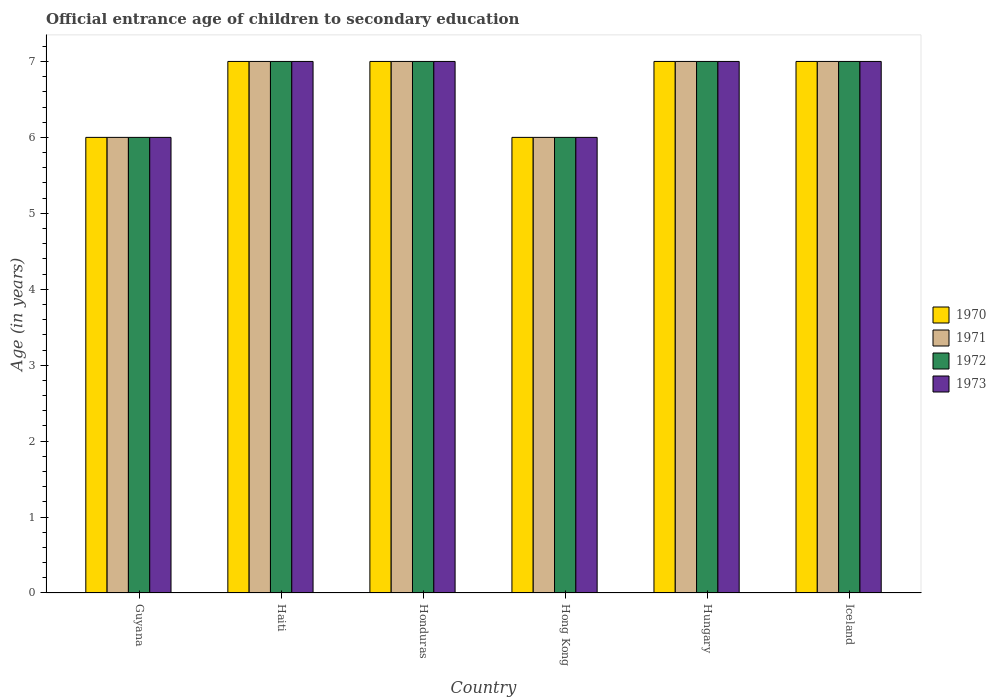Are the number of bars per tick equal to the number of legend labels?
Your answer should be compact. Yes. How many bars are there on the 3rd tick from the right?
Make the answer very short. 4. What is the label of the 1st group of bars from the left?
Offer a terse response. Guyana. Across all countries, what is the minimum secondary school starting age of children in 1973?
Provide a succinct answer. 6. In which country was the secondary school starting age of children in 1973 maximum?
Provide a short and direct response. Haiti. In which country was the secondary school starting age of children in 1972 minimum?
Your response must be concise. Guyana. What is the difference between the secondary school starting age of children in 1972 in Haiti and that in Hungary?
Offer a terse response. 0. What is the average secondary school starting age of children in 1971 per country?
Your answer should be compact. 6.67. What is the difference between the secondary school starting age of children of/in 1971 and secondary school starting age of children of/in 1973 in Hungary?
Give a very brief answer. 0. In how many countries, is the secondary school starting age of children in 1970 greater than 5.8 years?
Provide a short and direct response. 6. What is the ratio of the secondary school starting age of children in 1970 in Guyana to that in Haiti?
Your answer should be compact. 0.86. Is the secondary school starting age of children in 1970 in Guyana less than that in Hungary?
Ensure brevity in your answer.  Yes. What does the 3rd bar from the right in Guyana represents?
Make the answer very short. 1971. How many bars are there?
Your answer should be compact. 24. How many countries are there in the graph?
Keep it short and to the point. 6. What is the title of the graph?
Make the answer very short. Official entrance age of children to secondary education. Does "1998" appear as one of the legend labels in the graph?
Ensure brevity in your answer.  No. What is the label or title of the Y-axis?
Your response must be concise. Age (in years). What is the Age (in years) in 1972 in Guyana?
Make the answer very short. 6. What is the Age (in years) in 1970 in Haiti?
Give a very brief answer. 7. What is the Age (in years) in 1971 in Haiti?
Your answer should be very brief. 7. What is the Age (in years) of 1972 in Haiti?
Offer a very short reply. 7. What is the Age (in years) in 1973 in Haiti?
Keep it short and to the point. 7. What is the Age (in years) in 1970 in Honduras?
Your response must be concise. 7. What is the Age (in years) of 1973 in Honduras?
Your response must be concise. 7. What is the Age (in years) of 1970 in Hong Kong?
Offer a terse response. 6. What is the Age (in years) of 1973 in Hong Kong?
Keep it short and to the point. 6. What is the Age (in years) in 1970 in Hungary?
Offer a terse response. 7. What is the Age (in years) in 1972 in Hungary?
Your answer should be very brief. 7. What is the Age (in years) of 1973 in Hungary?
Your response must be concise. 7. What is the Age (in years) in 1973 in Iceland?
Give a very brief answer. 7. Across all countries, what is the minimum Age (in years) in 1973?
Provide a short and direct response. 6. What is the total Age (in years) in 1970 in the graph?
Keep it short and to the point. 40. What is the total Age (in years) of 1971 in the graph?
Keep it short and to the point. 40. What is the total Age (in years) in 1972 in the graph?
Offer a terse response. 40. What is the total Age (in years) in 1973 in the graph?
Your answer should be very brief. 40. What is the difference between the Age (in years) in 1970 in Guyana and that in Haiti?
Keep it short and to the point. -1. What is the difference between the Age (in years) of 1972 in Guyana and that in Haiti?
Your answer should be very brief. -1. What is the difference between the Age (in years) of 1971 in Guyana and that in Honduras?
Offer a terse response. -1. What is the difference between the Age (in years) of 1973 in Guyana and that in Honduras?
Keep it short and to the point. -1. What is the difference between the Age (in years) of 1970 in Guyana and that in Hong Kong?
Give a very brief answer. 0. What is the difference between the Age (in years) in 1970 in Guyana and that in Hungary?
Make the answer very short. -1. What is the difference between the Age (in years) of 1972 in Guyana and that in Hungary?
Provide a short and direct response. -1. What is the difference between the Age (in years) in 1973 in Guyana and that in Hungary?
Your response must be concise. -1. What is the difference between the Age (in years) in 1970 in Guyana and that in Iceland?
Your response must be concise. -1. What is the difference between the Age (in years) of 1972 in Guyana and that in Iceland?
Your answer should be very brief. -1. What is the difference between the Age (in years) of 1973 in Guyana and that in Iceland?
Your answer should be very brief. -1. What is the difference between the Age (in years) in 1971 in Haiti and that in Honduras?
Make the answer very short. 0. What is the difference between the Age (in years) of 1970 in Haiti and that in Hong Kong?
Offer a very short reply. 1. What is the difference between the Age (in years) of 1972 in Haiti and that in Hong Kong?
Provide a succinct answer. 1. What is the difference between the Age (in years) in 1970 in Haiti and that in Hungary?
Offer a very short reply. 0. What is the difference between the Age (in years) in 1971 in Haiti and that in Hungary?
Provide a short and direct response. 0. What is the difference between the Age (in years) in 1973 in Haiti and that in Hungary?
Provide a short and direct response. 0. What is the difference between the Age (in years) of 1971 in Haiti and that in Iceland?
Ensure brevity in your answer.  0. What is the difference between the Age (in years) of 1972 in Haiti and that in Iceland?
Give a very brief answer. 0. What is the difference between the Age (in years) in 1973 in Haiti and that in Iceland?
Ensure brevity in your answer.  0. What is the difference between the Age (in years) of 1972 in Honduras and that in Hong Kong?
Give a very brief answer. 1. What is the difference between the Age (in years) in 1973 in Honduras and that in Hong Kong?
Make the answer very short. 1. What is the difference between the Age (in years) in 1970 in Honduras and that in Hungary?
Provide a short and direct response. 0. What is the difference between the Age (in years) in 1971 in Honduras and that in Hungary?
Provide a succinct answer. 0. What is the difference between the Age (in years) in 1972 in Honduras and that in Hungary?
Make the answer very short. 0. What is the difference between the Age (in years) in 1973 in Honduras and that in Iceland?
Your answer should be compact. 0. What is the difference between the Age (in years) of 1971 in Hong Kong and that in Hungary?
Keep it short and to the point. -1. What is the difference between the Age (in years) of 1973 in Hong Kong and that in Hungary?
Ensure brevity in your answer.  -1. What is the difference between the Age (in years) of 1972 in Hong Kong and that in Iceland?
Offer a terse response. -1. What is the difference between the Age (in years) of 1973 in Hong Kong and that in Iceland?
Your response must be concise. -1. What is the difference between the Age (in years) in 1972 in Hungary and that in Iceland?
Your answer should be compact. 0. What is the difference between the Age (in years) of 1973 in Hungary and that in Iceland?
Offer a terse response. 0. What is the difference between the Age (in years) in 1971 in Guyana and the Age (in years) in 1972 in Haiti?
Offer a very short reply. -1. What is the difference between the Age (in years) of 1971 in Guyana and the Age (in years) of 1973 in Haiti?
Ensure brevity in your answer.  -1. What is the difference between the Age (in years) in 1970 in Guyana and the Age (in years) in 1972 in Honduras?
Ensure brevity in your answer.  -1. What is the difference between the Age (in years) of 1971 in Guyana and the Age (in years) of 1973 in Honduras?
Keep it short and to the point. -1. What is the difference between the Age (in years) in 1970 in Guyana and the Age (in years) in 1971 in Hong Kong?
Ensure brevity in your answer.  0. What is the difference between the Age (in years) in 1970 in Guyana and the Age (in years) in 1972 in Hong Kong?
Provide a short and direct response. 0. What is the difference between the Age (in years) in 1971 in Guyana and the Age (in years) in 1972 in Hong Kong?
Your answer should be compact. 0. What is the difference between the Age (in years) of 1970 in Guyana and the Age (in years) of 1971 in Hungary?
Make the answer very short. -1. What is the difference between the Age (in years) of 1970 in Guyana and the Age (in years) of 1972 in Hungary?
Provide a succinct answer. -1. What is the difference between the Age (in years) of 1970 in Guyana and the Age (in years) of 1971 in Iceland?
Offer a terse response. -1. What is the difference between the Age (in years) of 1970 in Guyana and the Age (in years) of 1972 in Iceland?
Your answer should be compact. -1. What is the difference between the Age (in years) of 1971 in Guyana and the Age (in years) of 1973 in Iceland?
Your answer should be very brief. -1. What is the difference between the Age (in years) of 1972 in Guyana and the Age (in years) of 1973 in Iceland?
Ensure brevity in your answer.  -1. What is the difference between the Age (in years) of 1970 in Haiti and the Age (in years) of 1971 in Honduras?
Give a very brief answer. 0. What is the difference between the Age (in years) of 1970 in Haiti and the Age (in years) of 1972 in Honduras?
Your response must be concise. 0. What is the difference between the Age (in years) of 1971 in Haiti and the Age (in years) of 1972 in Honduras?
Provide a succinct answer. 0. What is the difference between the Age (in years) in 1971 in Haiti and the Age (in years) in 1973 in Honduras?
Provide a short and direct response. 0. What is the difference between the Age (in years) in 1970 in Haiti and the Age (in years) in 1972 in Hong Kong?
Keep it short and to the point. 1. What is the difference between the Age (in years) of 1970 in Haiti and the Age (in years) of 1973 in Hong Kong?
Offer a very short reply. 1. What is the difference between the Age (in years) in 1971 in Haiti and the Age (in years) in 1972 in Hong Kong?
Offer a terse response. 1. What is the difference between the Age (in years) in 1970 in Haiti and the Age (in years) in 1972 in Hungary?
Keep it short and to the point. 0. What is the difference between the Age (in years) in 1970 in Haiti and the Age (in years) in 1973 in Hungary?
Make the answer very short. 0. What is the difference between the Age (in years) in 1971 in Haiti and the Age (in years) in 1972 in Hungary?
Keep it short and to the point. 0. What is the difference between the Age (in years) of 1971 in Haiti and the Age (in years) of 1973 in Hungary?
Your answer should be very brief. 0. What is the difference between the Age (in years) in 1970 in Haiti and the Age (in years) in 1971 in Iceland?
Your response must be concise. 0. What is the difference between the Age (in years) in 1970 in Haiti and the Age (in years) in 1973 in Iceland?
Make the answer very short. 0. What is the difference between the Age (in years) of 1971 in Haiti and the Age (in years) of 1972 in Iceland?
Make the answer very short. 0. What is the difference between the Age (in years) in 1972 in Haiti and the Age (in years) in 1973 in Iceland?
Your answer should be very brief. 0. What is the difference between the Age (in years) of 1970 in Honduras and the Age (in years) of 1971 in Hong Kong?
Your answer should be very brief. 1. What is the difference between the Age (in years) of 1970 in Honduras and the Age (in years) of 1972 in Hong Kong?
Offer a terse response. 1. What is the difference between the Age (in years) in 1970 in Honduras and the Age (in years) in 1971 in Hungary?
Your answer should be compact. 0. What is the difference between the Age (in years) of 1971 in Honduras and the Age (in years) of 1972 in Hungary?
Provide a short and direct response. 0. What is the difference between the Age (in years) of 1972 in Honduras and the Age (in years) of 1973 in Hungary?
Provide a succinct answer. 0. What is the difference between the Age (in years) of 1970 in Honduras and the Age (in years) of 1972 in Iceland?
Offer a very short reply. 0. What is the difference between the Age (in years) of 1970 in Honduras and the Age (in years) of 1973 in Iceland?
Provide a succinct answer. 0. What is the difference between the Age (in years) of 1971 in Honduras and the Age (in years) of 1973 in Iceland?
Provide a succinct answer. 0. What is the difference between the Age (in years) in 1970 in Hong Kong and the Age (in years) in 1971 in Hungary?
Offer a terse response. -1. What is the difference between the Age (in years) of 1970 in Hong Kong and the Age (in years) of 1972 in Hungary?
Offer a very short reply. -1. What is the difference between the Age (in years) in 1971 in Hong Kong and the Age (in years) in 1972 in Hungary?
Keep it short and to the point. -1. What is the difference between the Age (in years) of 1971 in Hong Kong and the Age (in years) of 1973 in Hungary?
Your response must be concise. -1. What is the difference between the Age (in years) in 1972 in Hong Kong and the Age (in years) in 1973 in Hungary?
Keep it short and to the point. -1. What is the difference between the Age (in years) of 1970 in Hong Kong and the Age (in years) of 1971 in Iceland?
Make the answer very short. -1. What is the difference between the Age (in years) of 1970 in Hong Kong and the Age (in years) of 1973 in Iceland?
Give a very brief answer. -1. What is the difference between the Age (in years) of 1971 in Hong Kong and the Age (in years) of 1973 in Iceland?
Offer a terse response. -1. What is the difference between the Age (in years) of 1970 in Hungary and the Age (in years) of 1973 in Iceland?
Your response must be concise. 0. What is the difference between the Age (in years) of 1971 in Hungary and the Age (in years) of 1973 in Iceland?
Provide a succinct answer. 0. What is the average Age (in years) in 1972 per country?
Your answer should be compact. 6.67. What is the average Age (in years) of 1973 per country?
Offer a very short reply. 6.67. What is the difference between the Age (in years) in 1971 and Age (in years) in 1973 in Guyana?
Make the answer very short. 0. What is the difference between the Age (in years) of 1970 and Age (in years) of 1973 in Haiti?
Your answer should be compact. 0. What is the difference between the Age (in years) in 1971 and Age (in years) in 1972 in Haiti?
Offer a very short reply. 0. What is the difference between the Age (in years) in 1972 and Age (in years) in 1973 in Haiti?
Offer a very short reply. 0. What is the difference between the Age (in years) of 1970 and Age (in years) of 1972 in Honduras?
Keep it short and to the point. 0. What is the difference between the Age (in years) of 1970 and Age (in years) of 1973 in Honduras?
Offer a very short reply. 0. What is the difference between the Age (in years) of 1971 and Age (in years) of 1972 in Honduras?
Provide a succinct answer. 0. What is the difference between the Age (in years) in 1971 and Age (in years) in 1973 in Honduras?
Ensure brevity in your answer.  0. What is the difference between the Age (in years) in 1972 and Age (in years) in 1973 in Honduras?
Ensure brevity in your answer.  0. What is the difference between the Age (in years) of 1970 and Age (in years) of 1971 in Hong Kong?
Keep it short and to the point. 0. What is the difference between the Age (in years) of 1970 and Age (in years) of 1973 in Hong Kong?
Provide a short and direct response. 0. What is the difference between the Age (in years) in 1971 and Age (in years) in 1972 in Hungary?
Provide a succinct answer. 0. What is the difference between the Age (in years) of 1970 and Age (in years) of 1973 in Iceland?
Offer a very short reply. 0. What is the difference between the Age (in years) of 1971 and Age (in years) of 1972 in Iceland?
Provide a succinct answer. 0. What is the difference between the Age (in years) in 1971 and Age (in years) in 1973 in Iceland?
Your answer should be very brief. 0. What is the ratio of the Age (in years) of 1970 in Guyana to that in Haiti?
Offer a very short reply. 0.86. What is the ratio of the Age (in years) of 1973 in Guyana to that in Haiti?
Offer a terse response. 0.86. What is the ratio of the Age (in years) in 1973 in Guyana to that in Honduras?
Offer a very short reply. 0.86. What is the ratio of the Age (in years) in 1971 in Guyana to that in Hong Kong?
Your answer should be very brief. 1. What is the ratio of the Age (in years) in 1972 in Guyana to that in Hong Kong?
Make the answer very short. 1. What is the ratio of the Age (in years) of 1973 in Guyana to that in Hong Kong?
Provide a short and direct response. 1. What is the ratio of the Age (in years) of 1972 in Guyana to that in Hungary?
Offer a terse response. 0.86. What is the ratio of the Age (in years) in 1970 in Guyana to that in Iceland?
Offer a terse response. 0.86. What is the ratio of the Age (in years) in 1971 in Guyana to that in Iceland?
Offer a terse response. 0.86. What is the ratio of the Age (in years) of 1973 in Guyana to that in Iceland?
Offer a very short reply. 0.86. What is the ratio of the Age (in years) in 1970 in Haiti to that in Honduras?
Keep it short and to the point. 1. What is the ratio of the Age (in years) of 1972 in Haiti to that in Honduras?
Provide a succinct answer. 1. What is the ratio of the Age (in years) in 1973 in Haiti to that in Honduras?
Provide a short and direct response. 1. What is the ratio of the Age (in years) in 1970 in Haiti to that in Hong Kong?
Your response must be concise. 1.17. What is the ratio of the Age (in years) in 1972 in Haiti to that in Hong Kong?
Offer a terse response. 1.17. What is the ratio of the Age (in years) of 1973 in Haiti to that in Hong Kong?
Provide a succinct answer. 1.17. What is the ratio of the Age (in years) of 1970 in Haiti to that in Hungary?
Offer a terse response. 1. What is the ratio of the Age (in years) in 1971 in Haiti to that in Hungary?
Offer a very short reply. 1. What is the ratio of the Age (in years) of 1973 in Haiti to that in Hungary?
Your answer should be compact. 1. What is the ratio of the Age (in years) of 1970 in Haiti to that in Iceland?
Your answer should be compact. 1. What is the ratio of the Age (in years) in 1972 in Haiti to that in Iceland?
Your answer should be compact. 1. What is the ratio of the Age (in years) in 1970 in Honduras to that in Hong Kong?
Provide a short and direct response. 1.17. What is the ratio of the Age (in years) in 1971 in Honduras to that in Hong Kong?
Make the answer very short. 1.17. What is the ratio of the Age (in years) in 1973 in Honduras to that in Hong Kong?
Make the answer very short. 1.17. What is the ratio of the Age (in years) in 1971 in Honduras to that in Hungary?
Ensure brevity in your answer.  1. What is the ratio of the Age (in years) in 1972 in Honduras to that in Hungary?
Your response must be concise. 1. What is the ratio of the Age (in years) in 1970 in Honduras to that in Iceland?
Your response must be concise. 1. What is the ratio of the Age (in years) of 1971 in Honduras to that in Iceland?
Offer a very short reply. 1. What is the ratio of the Age (in years) in 1970 in Hong Kong to that in Hungary?
Your answer should be compact. 0.86. What is the ratio of the Age (in years) in 1971 in Hong Kong to that in Hungary?
Your answer should be very brief. 0.86. What is the ratio of the Age (in years) of 1972 in Hong Kong to that in Hungary?
Keep it short and to the point. 0.86. What is the ratio of the Age (in years) in 1970 in Hong Kong to that in Iceland?
Give a very brief answer. 0.86. What is the ratio of the Age (in years) in 1972 in Hong Kong to that in Iceland?
Make the answer very short. 0.86. What is the ratio of the Age (in years) in 1972 in Hungary to that in Iceland?
Keep it short and to the point. 1. What is the ratio of the Age (in years) of 1973 in Hungary to that in Iceland?
Your answer should be very brief. 1. What is the difference between the highest and the second highest Age (in years) in 1971?
Offer a very short reply. 0. What is the difference between the highest and the second highest Age (in years) in 1973?
Provide a succinct answer. 0. What is the difference between the highest and the lowest Age (in years) in 1971?
Offer a very short reply. 1. What is the difference between the highest and the lowest Age (in years) in 1973?
Provide a succinct answer. 1. 